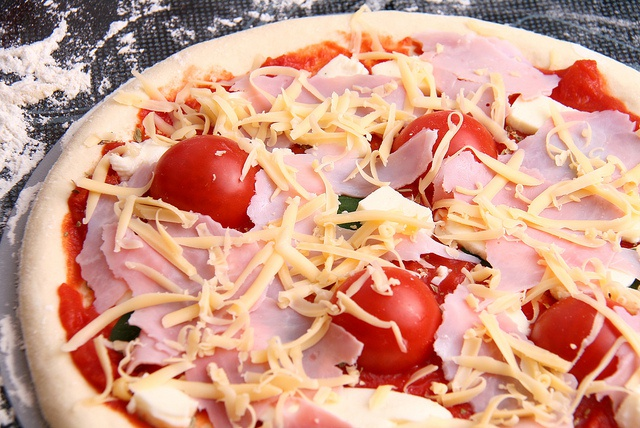Describe the objects in this image and their specific colors. I can see a pizza in black, lightgray, tan, and lightpink tones in this image. 